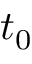Convert formula to latex. <formula><loc_0><loc_0><loc_500><loc_500>t _ { 0 }</formula> 